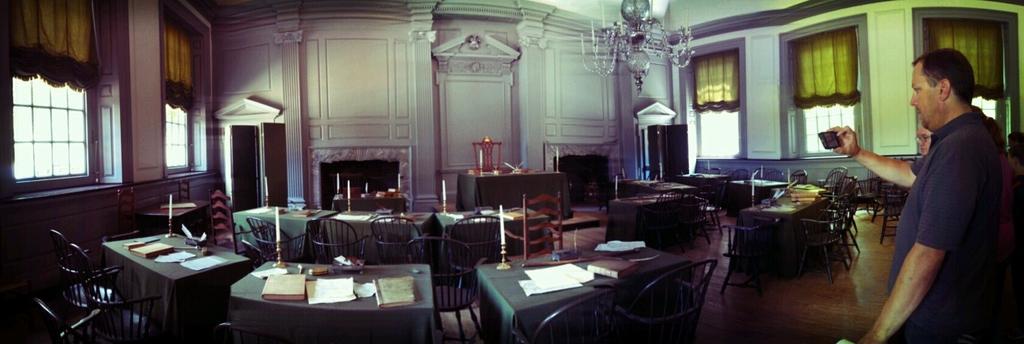Describe this image in one or two sentences. In this picture there are tables around the area of the image with chairs and there are windows around the area of the image, the person who is standing at the right side of the image he is taking the video of the area, it is seems to be a church. 